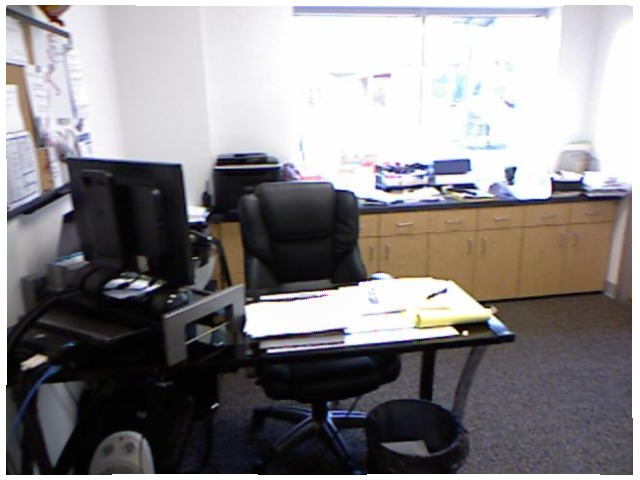<image>
Is the monitor under the chair? No. The monitor is not positioned under the chair. The vertical relationship between these objects is different. Is the table in front of the chair? Yes. The table is positioned in front of the chair, appearing closer to the camera viewpoint. Where is the books in relation to the table? Is it on the table? Yes. Looking at the image, I can see the books is positioned on top of the table, with the table providing support. Where is the table in relation to the chair? Is it behind the chair? Yes. From this viewpoint, the table is positioned behind the chair, with the chair partially or fully occluding the table. 